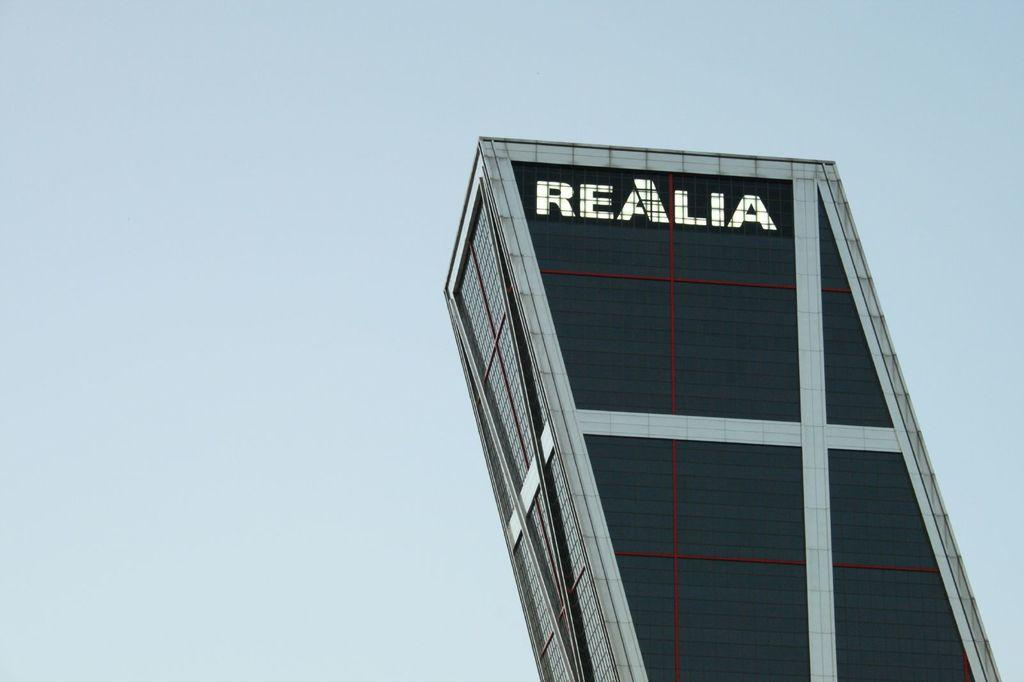What is the main subject of the picture? The main subject of the picture is a building. Are there any words or letters on the building? Yes, there is text on the building. What can be seen in the sky in the picture? The sky is visible at the top of the picture. How many sticks are being held by the grandfather in the image? There is no grandfather or sticks present in the image. What is the thumb doing in the image? There is no thumb present in the image. 